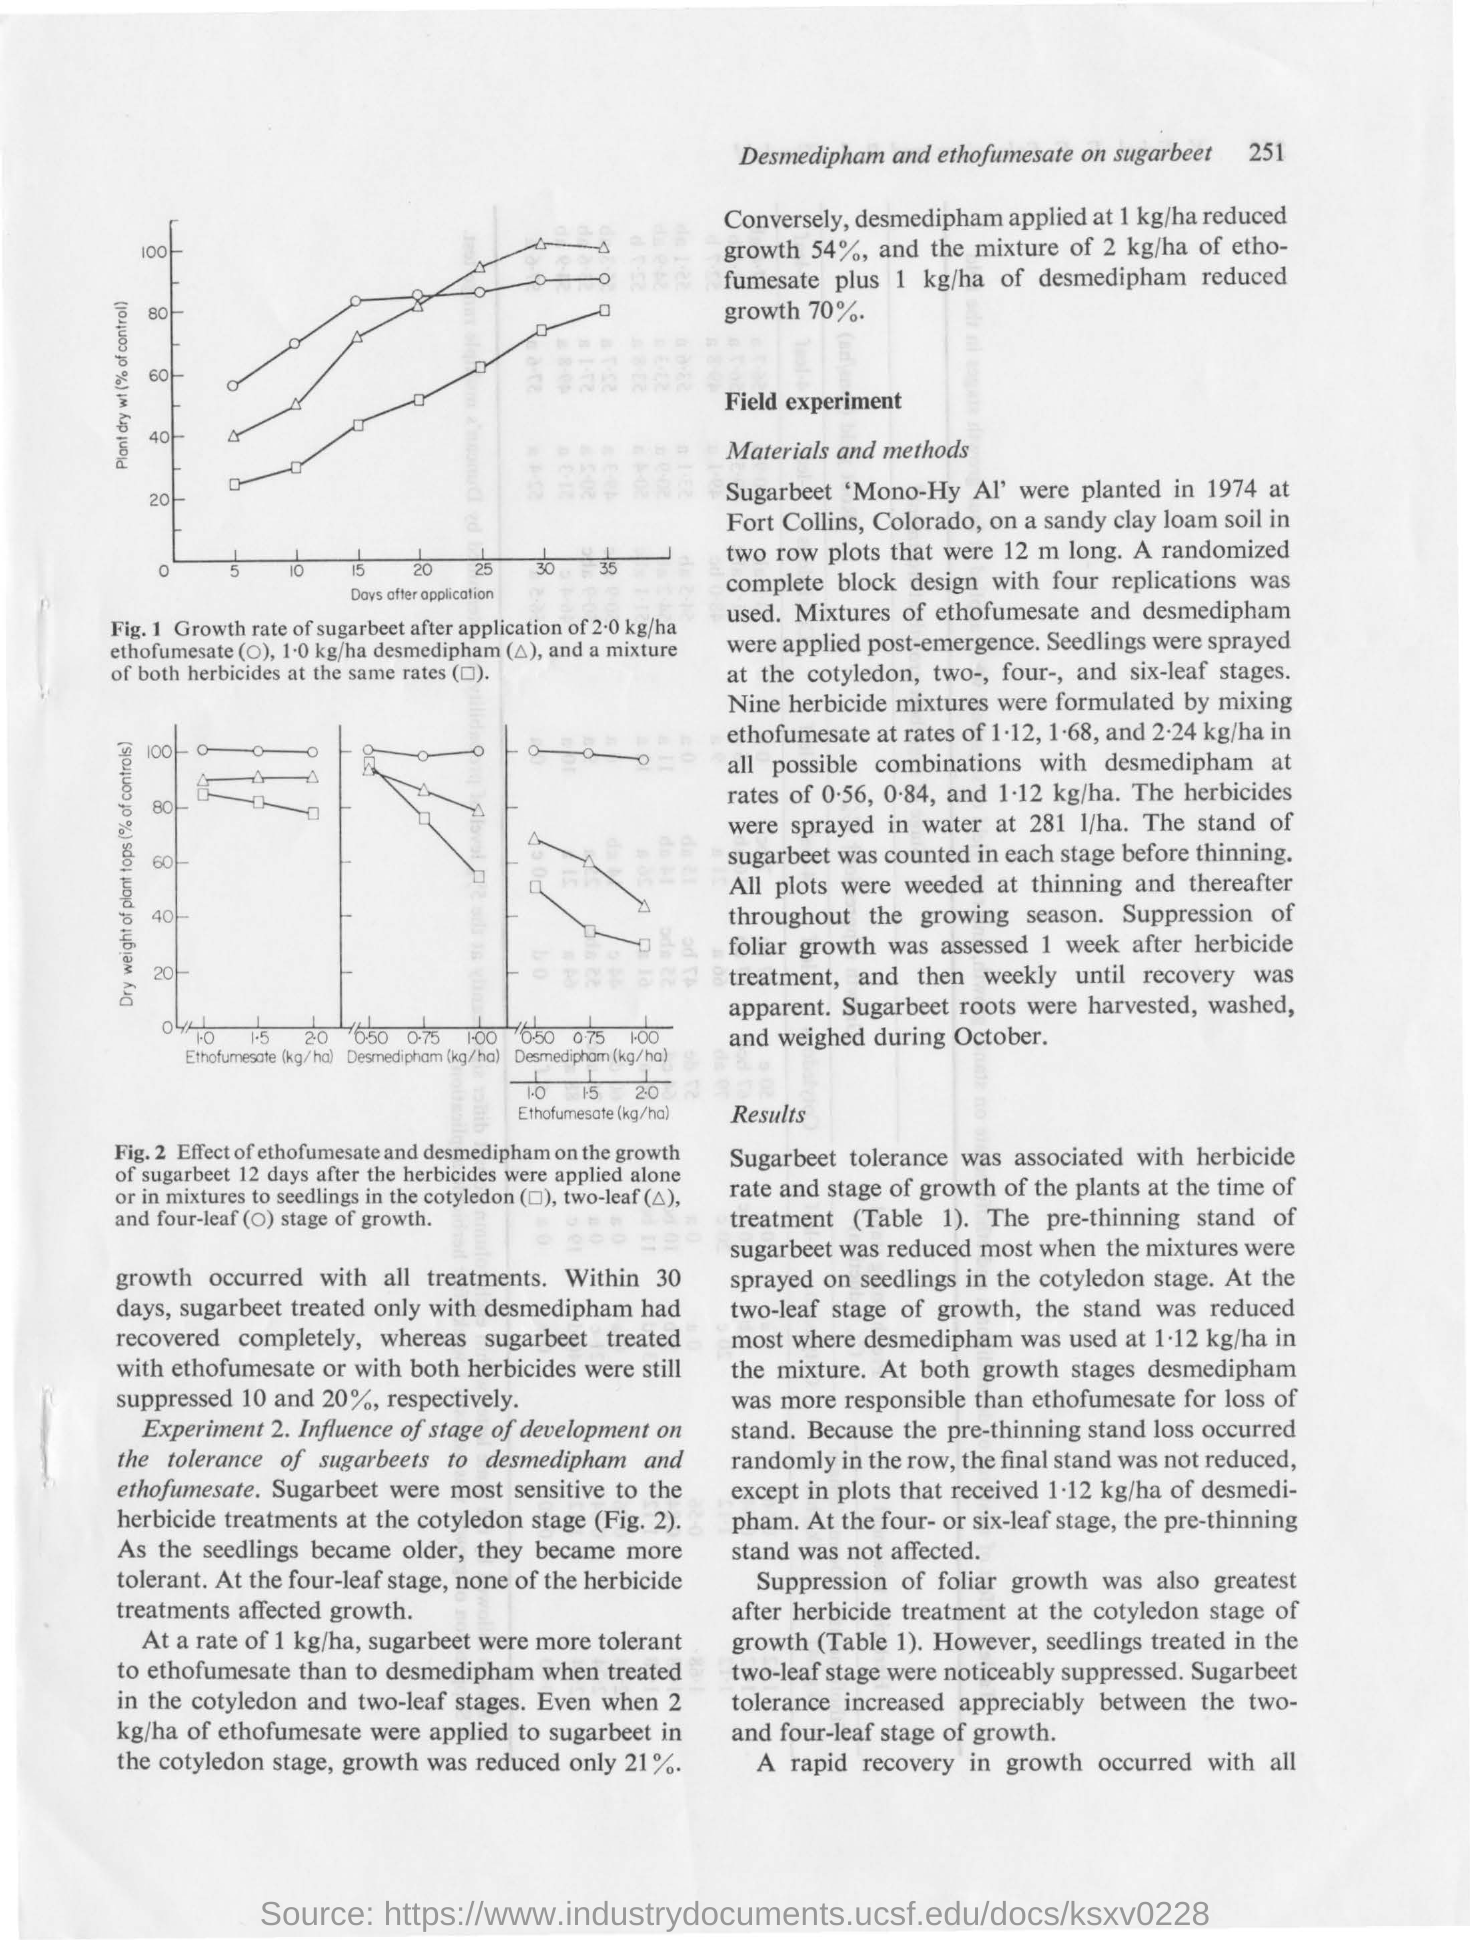What is title on the x axis of fig.1?
Offer a very short reply. DAYS AFTER APPLICATION. What is title on the y axis of fig.1?
Offer a very short reply. PLANT DRY WT(% OF CONTROL). What is title on the y axis of fig.2?
Offer a terse response. Dry weight of plant tops (% of controls). 